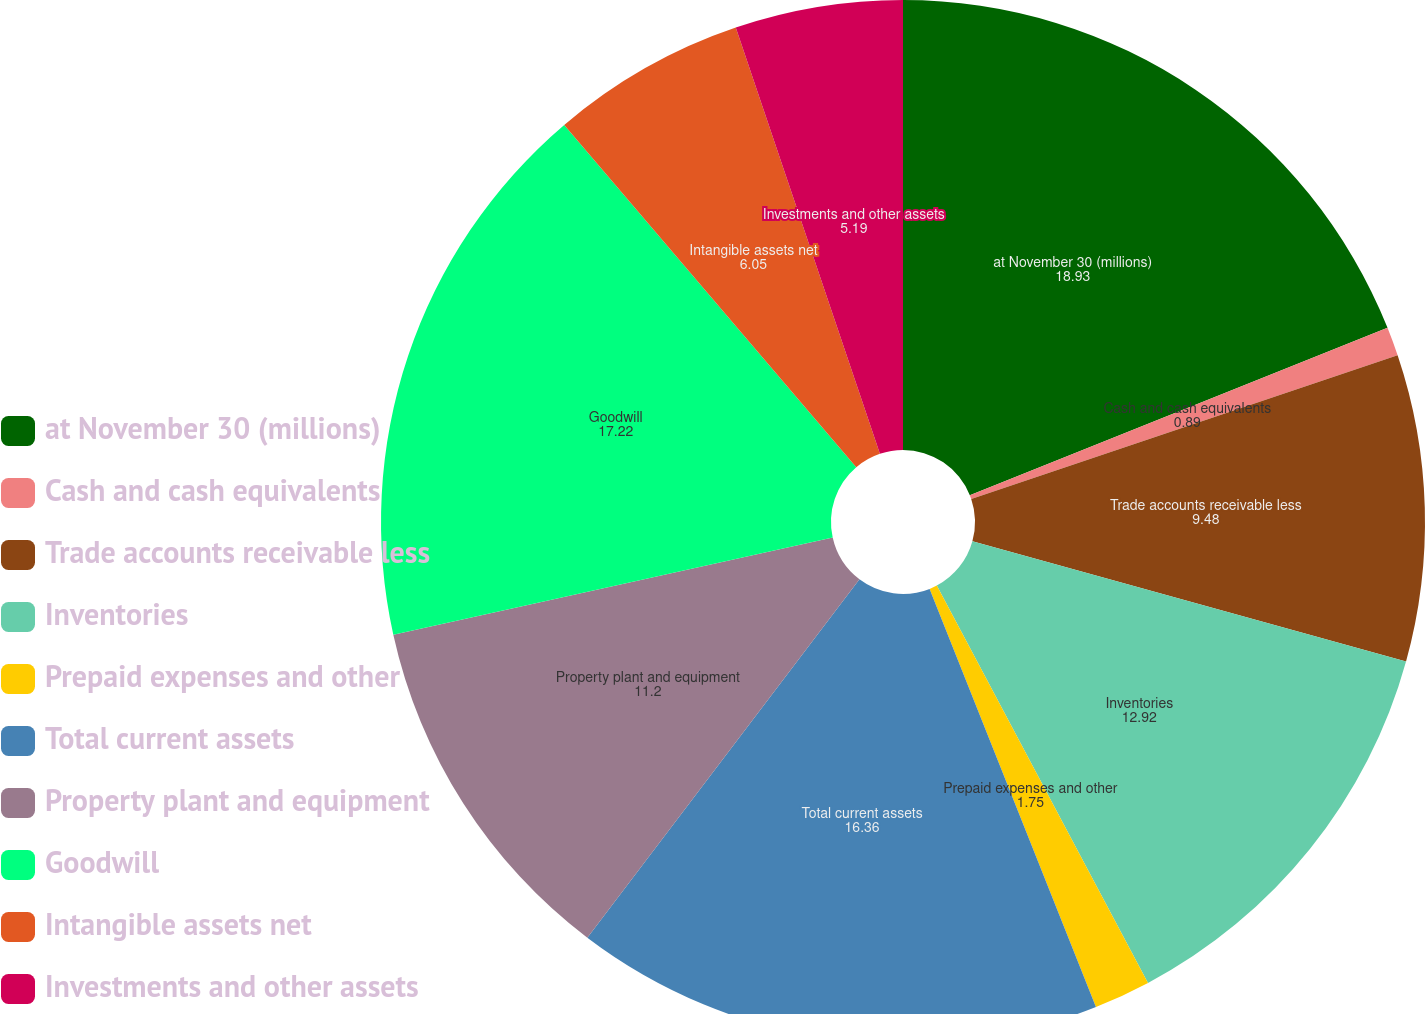Convert chart to OTSL. <chart><loc_0><loc_0><loc_500><loc_500><pie_chart><fcel>at November 30 (millions)<fcel>Cash and cash equivalents<fcel>Trade accounts receivable less<fcel>Inventories<fcel>Prepaid expenses and other<fcel>Total current assets<fcel>Property plant and equipment<fcel>Goodwill<fcel>Intangible assets net<fcel>Investments and other assets<nl><fcel>18.93%<fcel>0.89%<fcel>9.48%<fcel>12.92%<fcel>1.75%<fcel>16.36%<fcel>11.2%<fcel>17.22%<fcel>6.05%<fcel>5.19%<nl></chart> 